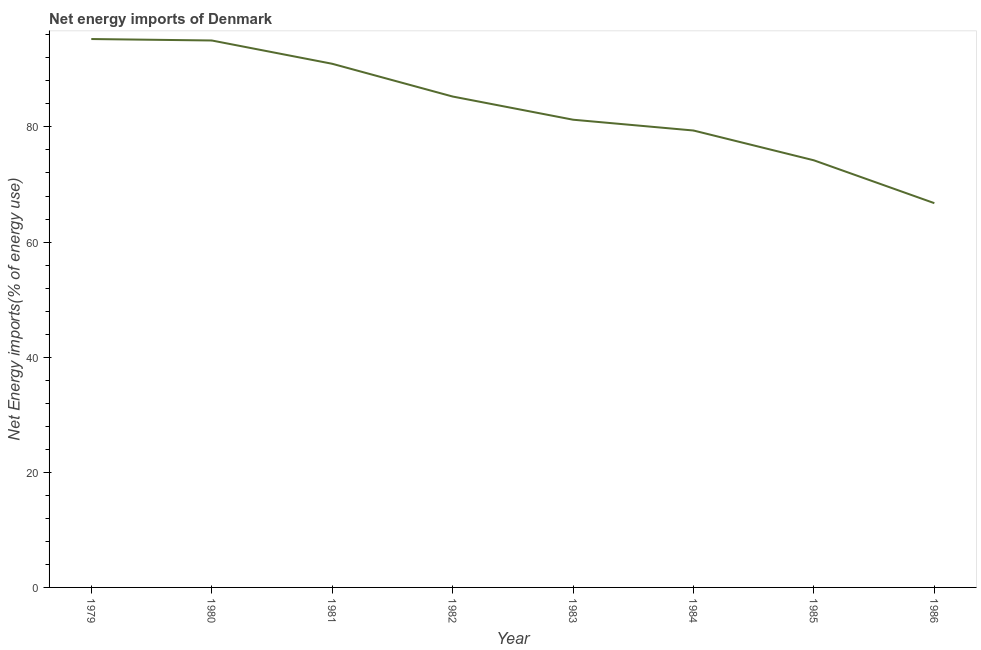What is the energy imports in 1980?
Provide a succinct answer. 95.02. Across all years, what is the maximum energy imports?
Your answer should be compact. 95.27. Across all years, what is the minimum energy imports?
Give a very brief answer. 66.76. In which year was the energy imports maximum?
Offer a terse response. 1979. What is the sum of the energy imports?
Keep it short and to the point. 668.16. What is the difference between the energy imports in 1983 and 1986?
Keep it short and to the point. 14.5. What is the average energy imports per year?
Keep it short and to the point. 83.52. What is the median energy imports?
Offer a terse response. 83.27. In how many years, is the energy imports greater than 92 %?
Give a very brief answer. 2. What is the ratio of the energy imports in 1981 to that in 1982?
Offer a terse response. 1.07. What is the difference between the highest and the second highest energy imports?
Your answer should be compact. 0.25. Is the sum of the energy imports in 1980 and 1983 greater than the maximum energy imports across all years?
Your answer should be compact. Yes. What is the difference between the highest and the lowest energy imports?
Your answer should be very brief. 28.51. In how many years, is the energy imports greater than the average energy imports taken over all years?
Give a very brief answer. 4. Does the energy imports monotonically increase over the years?
Give a very brief answer. No. How many years are there in the graph?
Your answer should be compact. 8. Are the values on the major ticks of Y-axis written in scientific E-notation?
Give a very brief answer. No. Does the graph contain grids?
Your answer should be very brief. No. What is the title of the graph?
Provide a short and direct response. Net energy imports of Denmark. What is the label or title of the Y-axis?
Make the answer very short. Net Energy imports(% of energy use). What is the Net Energy imports(% of energy use) in 1979?
Offer a terse response. 95.27. What is the Net Energy imports(% of energy use) in 1980?
Provide a short and direct response. 95.02. What is the Net Energy imports(% of energy use) in 1981?
Provide a succinct answer. 90.98. What is the Net Energy imports(% of energy use) in 1982?
Provide a succinct answer. 85.29. What is the Net Energy imports(% of energy use) in 1983?
Provide a succinct answer. 81.26. What is the Net Energy imports(% of energy use) of 1984?
Offer a terse response. 79.38. What is the Net Energy imports(% of energy use) in 1985?
Your answer should be compact. 74.2. What is the Net Energy imports(% of energy use) in 1986?
Make the answer very short. 66.76. What is the difference between the Net Energy imports(% of energy use) in 1979 and 1980?
Offer a very short reply. 0.25. What is the difference between the Net Energy imports(% of energy use) in 1979 and 1981?
Give a very brief answer. 4.3. What is the difference between the Net Energy imports(% of energy use) in 1979 and 1982?
Give a very brief answer. 9.99. What is the difference between the Net Energy imports(% of energy use) in 1979 and 1983?
Your response must be concise. 14.02. What is the difference between the Net Energy imports(% of energy use) in 1979 and 1984?
Make the answer very short. 15.89. What is the difference between the Net Energy imports(% of energy use) in 1979 and 1985?
Provide a succinct answer. 21.07. What is the difference between the Net Energy imports(% of energy use) in 1979 and 1986?
Offer a very short reply. 28.51. What is the difference between the Net Energy imports(% of energy use) in 1980 and 1981?
Keep it short and to the point. 4.05. What is the difference between the Net Energy imports(% of energy use) in 1980 and 1982?
Offer a very short reply. 9.74. What is the difference between the Net Energy imports(% of energy use) in 1980 and 1983?
Provide a succinct answer. 13.76. What is the difference between the Net Energy imports(% of energy use) in 1980 and 1984?
Make the answer very short. 15.64. What is the difference between the Net Energy imports(% of energy use) in 1980 and 1985?
Keep it short and to the point. 20.82. What is the difference between the Net Energy imports(% of energy use) in 1980 and 1986?
Ensure brevity in your answer.  28.26. What is the difference between the Net Energy imports(% of energy use) in 1981 and 1982?
Your answer should be compact. 5.69. What is the difference between the Net Energy imports(% of energy use) in 1981 and 1983?
Your answer should be very brief. 9.72. What is the difference between the Net Energy imports(% of energy use) in 1981 and 1984?
Offer a terse response. 11.59. What is the difference between the Net Energy imports(% of energy use) in 1981 and 1985?
Give a very brief answer. 16.77. What is the difference between the Net Energy imports(% of energy use) in 1981 and 1986?
Your response must be concise. 24.22. What is the difference between the Net Energy imports(% of energy use) in 1982 and 1983?
Your response must be concise. 4.03. What is the difference between the Net Energy imports(% of energy use) in 1982 and 1984?
Offer a terse response. 5.9. What is the difference between the Net Energy imports(% of energy use) in 1982 and 1985?
Provide a short and direct response. 11.08. What is the difference between the Net Energy imports(% of energy use) in 1982 and 1986?
Keep it short and to the point. 18.53. What is the difference between the Net Energy imports(% of energy use) in 1983 and 1984?
Give a very brief answer. 1.88. What is the difference between the Net Energy imports(% of energy use) in 1983 and 1985?
Provide a short and direct response. 7.06. What is the difference between the Net Energy imports(% of energy use) in 1983 and 1986?
Your response must be concise. 14.5. What is the difference between the Net Energy imports(% of energy use) in 1984 and 1985?
Your answer should be very brief. 5.18. What is the difference between the Net Energy imports(% of energy use) in 1984 and 1986?
Your answer should be compact. 12.62. What is the difference between the Net Energy imports(% of energy use) in 1985 and 1986?
Ensure brevity in your answer.  7.44. What is the ratio of the Net Energy imports(% of energy use) in 1979 to that in 1980?
Offer a very short reply. 1. What is the ratio of the Net Energy imports(% of energy use) in 1979 to that in 1981?
Provide a short and direct response. 1.05. What is the ratio of the Net Energy imports(% of energy use) in 1979 to that in 1982?
Offer a very short reply. 1.12. What is the ratio of the Net Energy imports(% of energy use) in 1979 to that in 1983?
Keep it short and to the point. 1.17. What is the ratio of the Net Energy imports(% of energy use) in 1979 to that in 1985?
Provide a short and direct response. 1.28. What is the ratio of the Net Energy imports(% of energy use) in 1979 to that in 1986?
Your answer should be very brief. 1.43. What is the ratio of the Net Energy imports(% of energy use) in 1980 to that in 1981?
Offer a very short reply. 1.04. What is the ratio of the Net Energy imports(% of energy use) in 1980 to that in 1982?
Keep it short and to the point. 1.11. What is the ratio of the Net Energy imports(% of energy use) in 1980 to that in 1983?
Your answer should be compact. 1.17. What is the ratio of the Net Energy imports(% of energy use) in 1980 to that in 1984?
Offer a very short reply. 1.2. What is the ratio of the Net Energy imports(% of energy use) in 1980 to that in 1985?
Offer a terse response. 1.28. What is the ratio of the Net Energy imports(% of energy use) in 1980 to that in 1986?
Make the answer very short. 1.42. What is the ratio of the Net Energy imports(% of energy use) in 1981 to that in 1982?
Offer a very short reply. 1.07. What is the ratio of the Net Energy imports(% of energy use) in 1981 to that in 1983?
Offer a very short reply. 1.12. What is the ratio of the Net Energy imports(% of energy use) in 1981 to that in 1984?
Make the answer very short. 1.15. What is the ratio of the Net Energy imports(% of energy use) in 1981 to that in 1985?
Give a very brief answer. 1.23. What is the ratio of the Net Energy imports(% of energy use) in 1981 to that in 1986?
Offer a very short reply. 1.36. What is the ratio of the Net Energy imports(% of energy use) in 1982 to that in 1984?
Your response must be concise. 1.07. What is the ratio of the Net Energy imports(% of energy use) in 1982 to that in 1985?
Offer a very short reply. 1.15. What is the ratio of the Net Energy imports(% of energy use) in 1982 to that in 1986?
Your answer should be compact. 1.28. What is the ratio of the Net Energy imports(% of energy use) in 1983 to that in 1984?
Keep it short and to the point. 1.02. What is the ratio of the Net Energy imports(% of energy use) in 1983 to that in 1985?
Make the answer very short. 1.09. What is the ratio of the Net Energy imports(% of energy use) in 1983 to that in 1986?
Make the answer very short. 1.22. What is the ratio of the Net Energy imports(% of energy use) in 1984 to that in 1985?
Keep it short and to the point. 1.07. What is the ratio of the Net Energy imports(% of energy use) in 1984 to that in 1986?
Provide a short and direct response. 1.19. What is the ratio of the Net Energy imports(% of energy use) in 1985 to that in 1986?
Offer a very short reply. 1.11. 